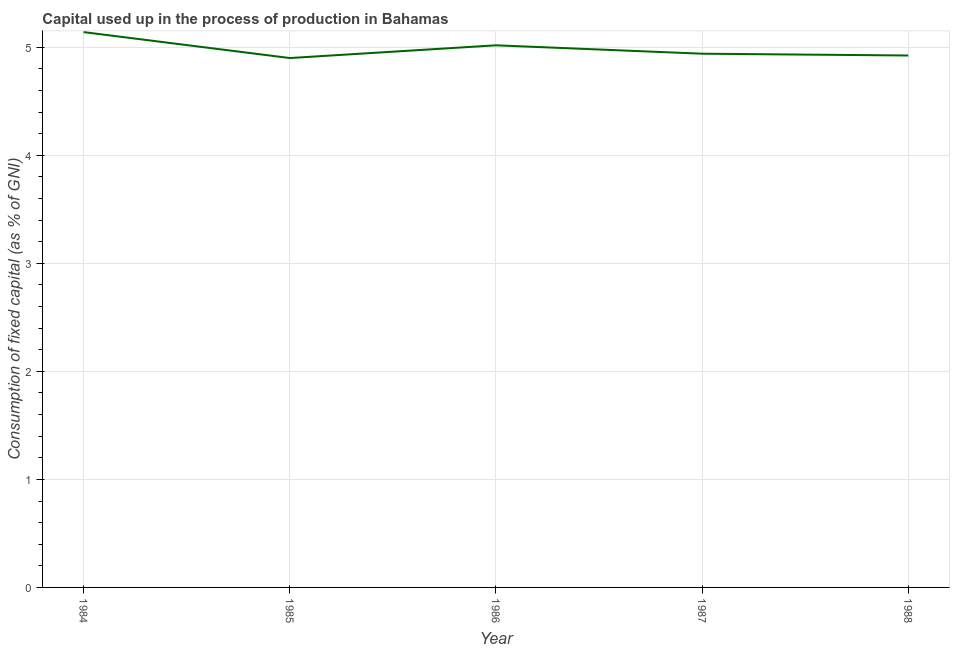What is the consumption of fixed capital in 1987?
Your answer should be very brief. 4.94. Across all years, what is the maximum consumption of fixed capital?
Provide a succinct answer. 5.14. Across all years, what is the minimum consumption of fixed capital?
Keep it short and to the point. 4.9. In which year was the consumption of fixed capital maximum?
Give a very brief answer. 1984. What is the sum of the consumption of fixed capital?
Ensure brevity in your answer.  24.92. What is the difference between the consumption of fixed capital in 1984 and 1988?
Offer a terse response. 0.22. What is the average consumption of fixed capital per year?
Provide a short and direct response. 4.98. What is the median consumption of fixed capital?
Your answer should be very brief. 4.94. Do a majority of the years between 1987 and 1985 (inclusive) have consumption of fixed capital greater than 2 %?
Provide a succinct answer. No. What is the ratio of the consumption of fixed capital in 1987 to that in 1988?
Offer a very short reply. 1. Is the consumption of fixed capital in 1984 less than that in 1985?
Offer a terse response. No. Is the difference between the consumption of fixed capital in 1985 and 1987 greater than the difference between any two years?
Provide a succinct answer. No. What is the difference between the highest and the second highest consumption of fixed capital?
Your response must be concise. 0.12. Is the sum of the consumption of fixed capital in 1985 and 1988 greater than the maximum consumption of fixed capital across all years?
Ensure brevity in your answer.  Yes. What is the difference between the highest and the lowest consumption of fixed capital?
Give a very brief answer. 0.24. Does the consumption of fixed capital monotonically increase over the years?
Your response must be concise. No. How many years are there in the graph?
Keep it short and to the point. 5. Are the values on the major ticks of Y-axis written in scientific E-notation?
Ensure brevity in your answer.  No. Does the graph contain grids?
Your response must be concise. Yes. What is the title of the graph?
Keep it short and to the point. Capital used up in the process of production in Bahamas. What is the label or title of the Y-axis?
Your answer should be very brief. Consumption of fixed capital (as % of GNI). What is the Consumption of fixed capital (as % of GNI) in 1984?
Your response must be concise. 5.14. What is the Consumption of fixed capital (as % of GNI) of 1985?
Ensure brevity in your answer.  4.9. What is the Consumption of fixed capital (as % of GNI) in 1986?
Provide a succinct answer. 5.02. What is the Consumption of fixed capital (as % of GNI) in 1987?
Offer a very short reply. 4.94. What is the Consumption of fixed capital (as % of GNI) of 1988?
Give a very brief answer. 4.92. What is the difference between the Consumption of fixed capital (as % of GNI) in 1984 and 1985?
Offer a very short reply. 0.24. What is the difference between the Consumption of fixed capital (as % of GNI) in 1984 and 1986?
Make the answer very short. 0.12. What is the difference between the Consumption of fixed capital (as % of GNI) in 1984 and 1987?
Make the answer very short. 0.2. What is the difference between the Consumption of fixed capital (as % of GNI) in 1984 and 1988?
Your answer should be very brief. 0.22. What is the difference between the Consumption of fixed capital (as % of GNI) in 1985 and 1986?
Give a very brief answer. -0.12. What is the difference between the Consumption of fixed capital (as % of GNI) in 1985 and 1987?
Your answer should be very brief. -0.04. What is the difference between the Consumption of fixed capital (as % of GNI) in 1985 and 1988?
Your response must be concise. -0.02. What is the difference between the Consumption of fixed capital (as % of GNI) in 1986 and 1987?
Make the answer very short. 0.08. What is the difference between the Consumption of fixed capital (as % of GNI) in 1986 and 1988?
Ensure brevity in your answer.  0.09. What is the difference between the Consumption of fixed capital (as % of GNI) in 1987 and 1988?
Your answer should be very brief. 0.02. What is the ratio of the Consumption of fixed capital (as % of GNI) in 1984 to that in 1985?
Keep it short and to the point. 1.05. What is the ratio of the Consumption of fixed capital (as % of GNI) in 1984 to that in 1986?
Your answer should be very brief. 1.02. What is the ratio of the Consumption of fixed capital (as % of GNI) in 1984 to that in 1988?
Offer a terse response. 1.04. What is the ratio of the Consumption of fixed capital (as % of GNI) in 1985 to that in 1987?
Your answer should be very brief. 0.99. What is the ratio of the Consumption of fixed capital (as % of GNI) in 1985 to that in 1988?
Give a very brief answer. 0.99. What is the ratio of the Consumption of fixed capital (as % of GNI) in 1986 to that in 1987?
Provide a succinct answer. 1.02. What is the ratio of the Consumption of fixed capital (as % of GNI) in 1986 to that in 1988?
Give a very brief answer. 1.02. What is the ratio of the Consumption of fixed capital (as % of GNI) in 1987 to that in 1988?
Ensure brevity in your answer.  1. 